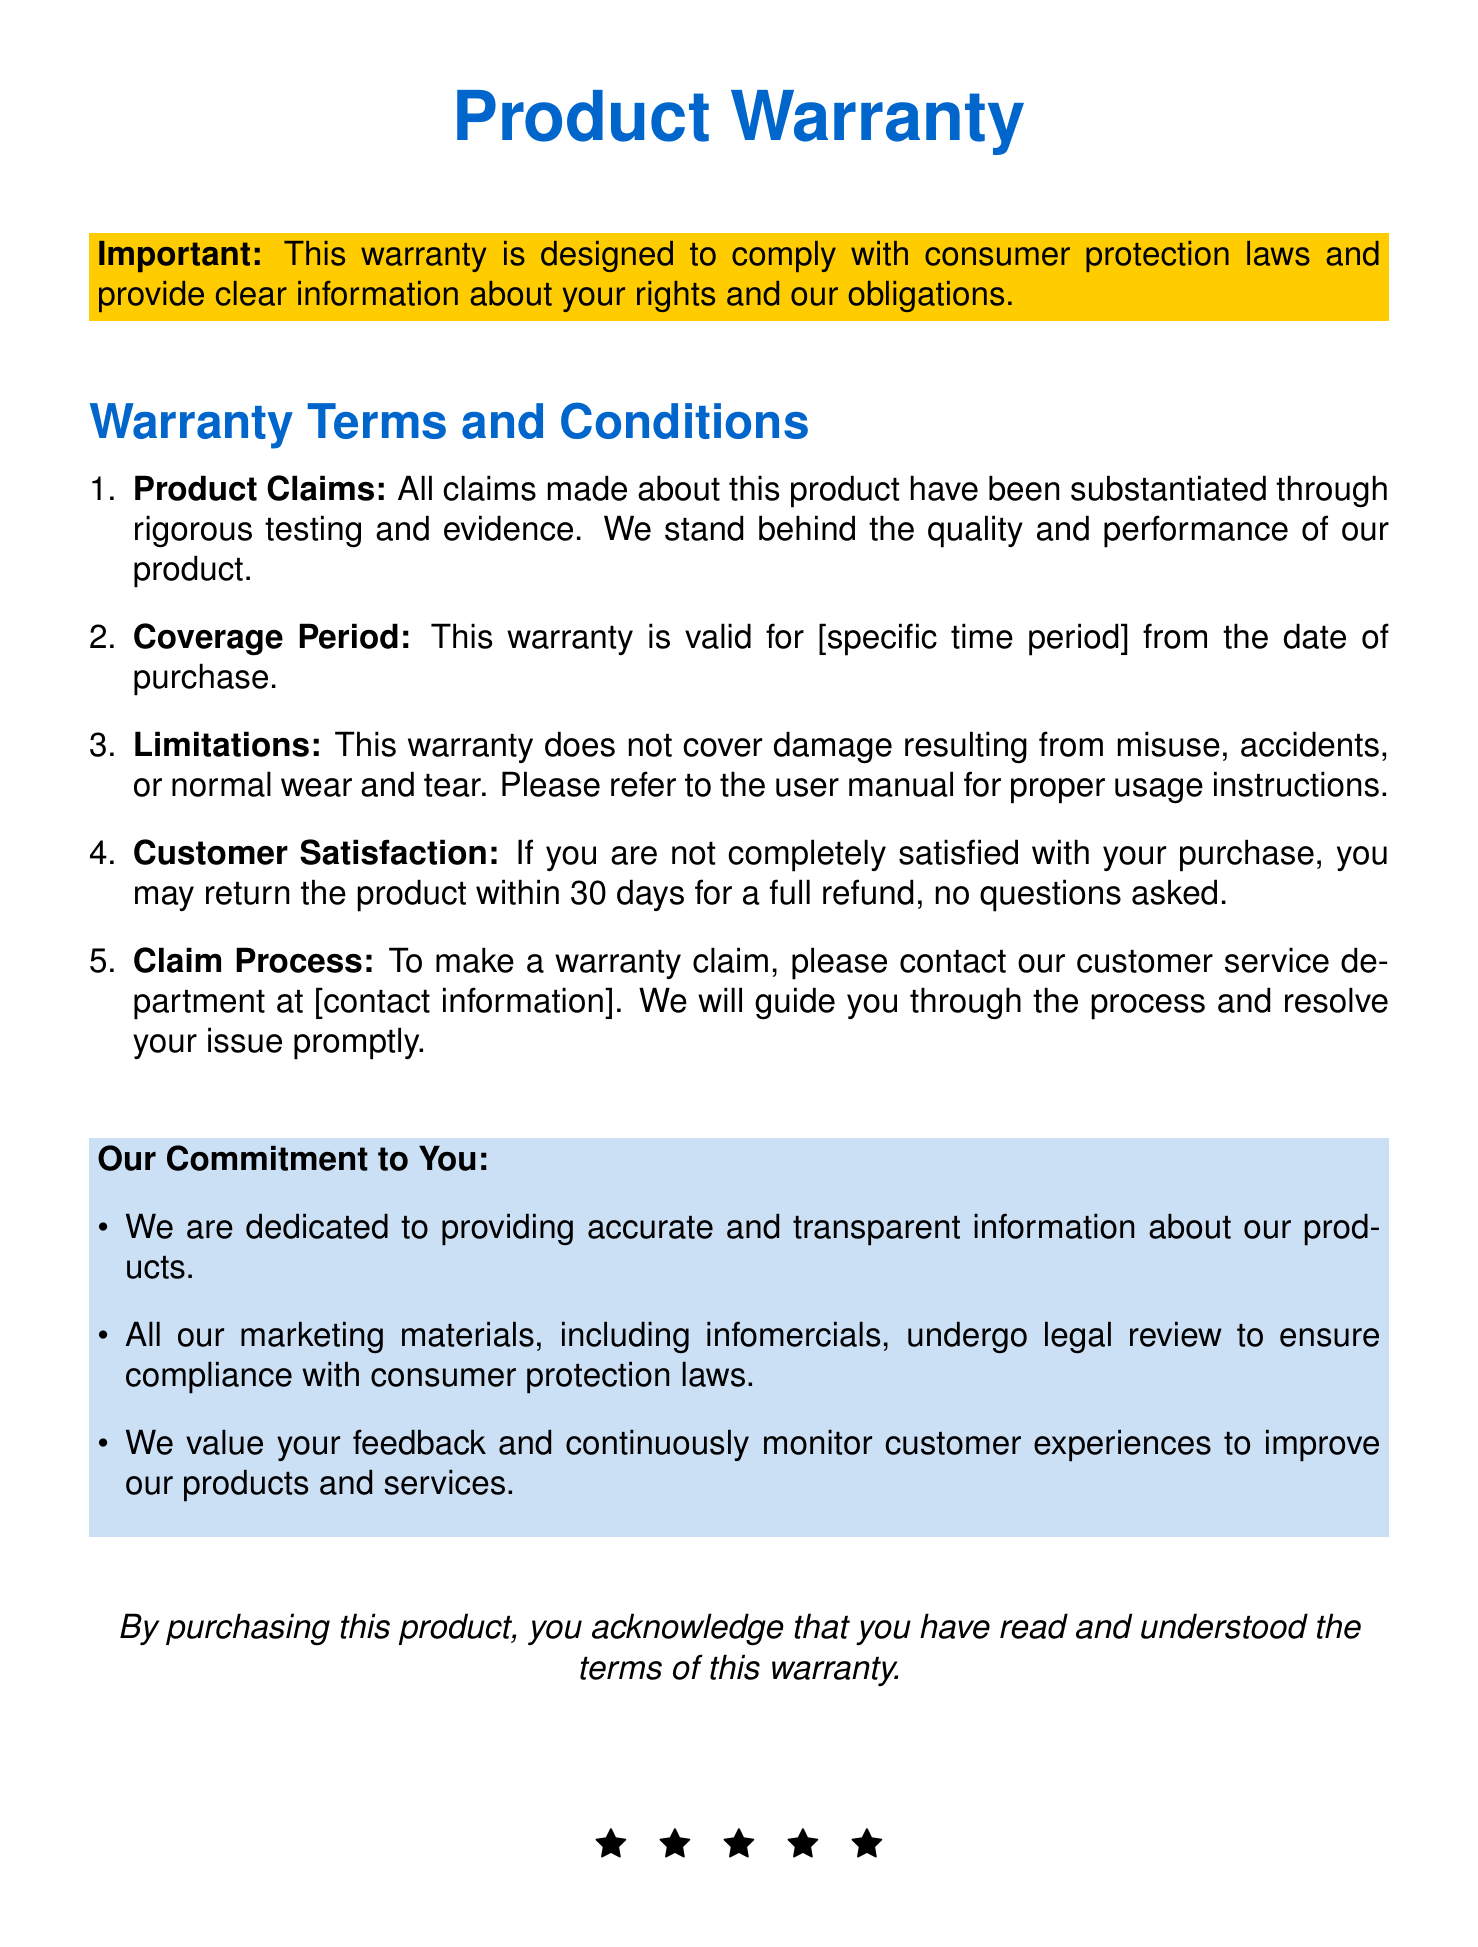What is the warranty coverage period? The document states a specific time period for warranty validity, but it is marked as [specific time period].
Answer: [specific time period] What is the satisfaction guarantee? It indicates that customers can return the product within 30 days for a full refund.
Answer: 30 days What does the warranty not cover? The warranty limitations specify exclusions for specific conditions like misuse.
Answer: Misuse, accidents, or normal wear and tear Who should be contacted for a warranty claim? The document specifies that customers should contact the customer service department for the claim process.
Answer: Customer service department What is the primary commitment stated in the warranty? The document lists the company's dedication to providing accurate and transparent product information.
Answer: Accurate and transparent information Are the marketing materials legally reviewed? The warranty mentions that all marketing materials, including infomercials, undergo legal review.
Answer: Yes What is required to acknowledge understanding of the warranty terms? The document states that by purchasing the product, one acknowledges reading and understanding the terms.
Answer: Purchasing the product What are customers encouraged to do regarding feedback? The warranty mentions that the company values feedback to monitor customer experiences.
Answer: Provide feedback 